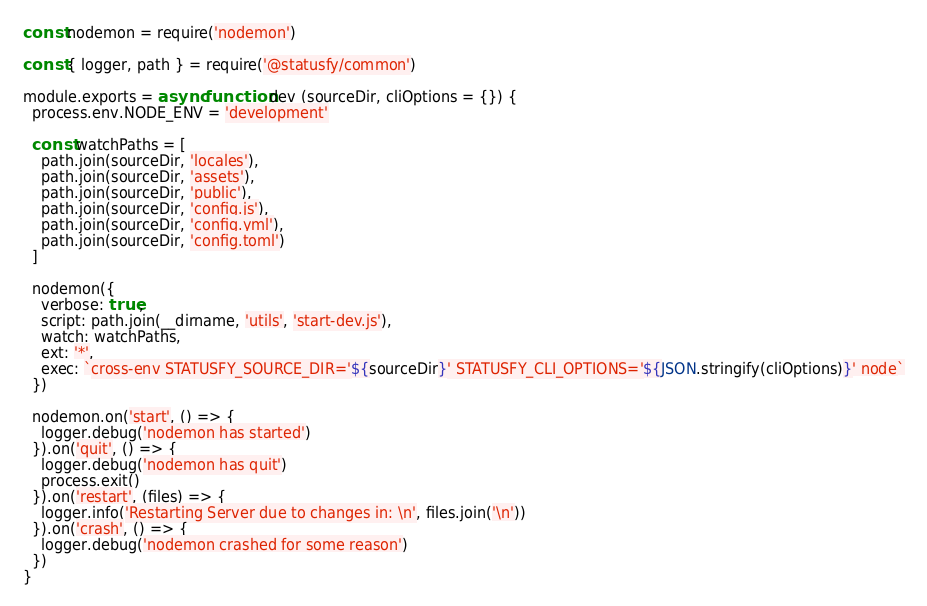<code> <loc_0><loc_0><loc_500><loc_500><_JavaScript_>const nodemon = require('nodemon')

const { logger, path } = require('@statusfy/common')

module.exports = async function dev (sourceDir, cliOptions = {}) {
  process.env.NODE_ENV = 'development'

  const watchPaths = [
    path.join(sourceDir, 'locales'),
    path.join(sourceDir, 'assets'),
    path.join(sourceDir, 'public'),
    path.join(sourceDir, 'config.js'),
    path.join(sourceDir, 'config.yml'),
    path.join(sourceDir, 'config.toml')
  ]

  nodemon({
    verbose: true,
    script: path.join(__dirname, 'utils', 'start-dev.js'),
    watch: watchPaths,
    ext: '*',
    exec: `cross-env STATUSFY_SOURCE_DIR='${sourceDir}' STATUSFY_CLI_OPTIONS='${JSON.stringify(cliOptions)}' node`
  })

  nodemon.on('start', () => {
    logger.debug('nodemon has started')
  }).on('quit', () => {
    logger.debug('nodemon has quit')
    process.exit()
  }).on('restart', (files) => {
    logger.info('Restarting Server due to changes in: \n', files.join('\n'))
  }).on('crash', () => {
    logger.debug('nodemon crashed for some reason')
  })
}
</code> 